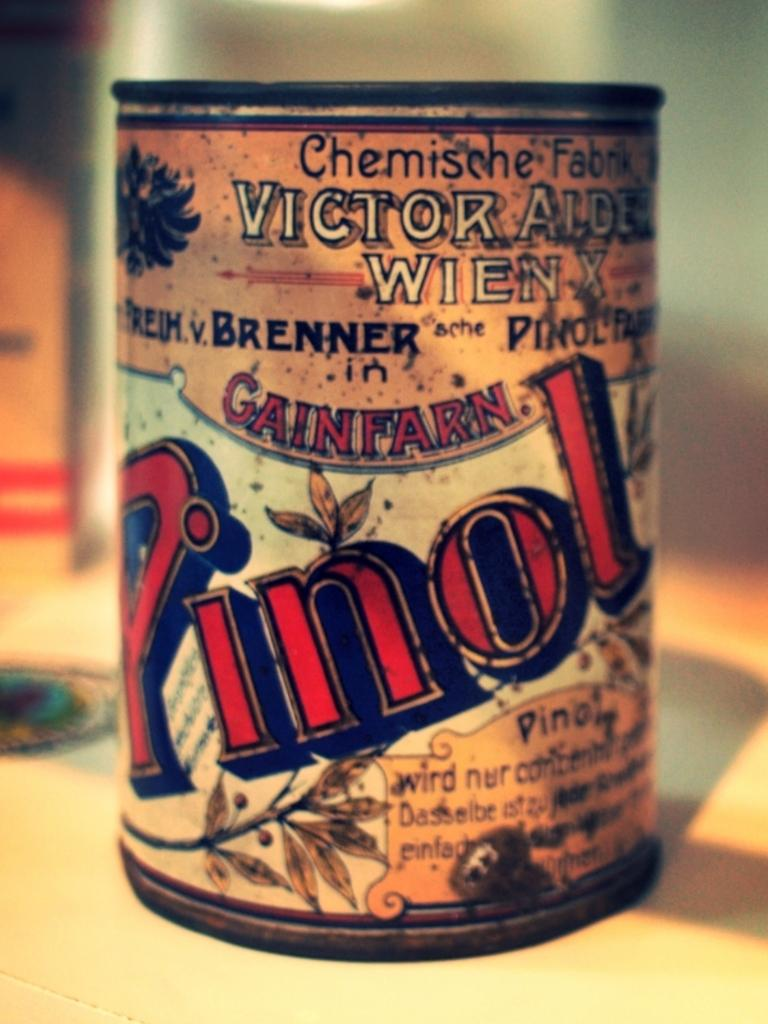Provide a one-sentence caption for the provided image. An old looking can with the wor Pinol visible on it. 